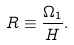Convert formula to latex. <formula><loc_0><loc_0><loc_500><loc_500>R \equiv \frac { \Omega _ { 1 } } { H } .</formula> 